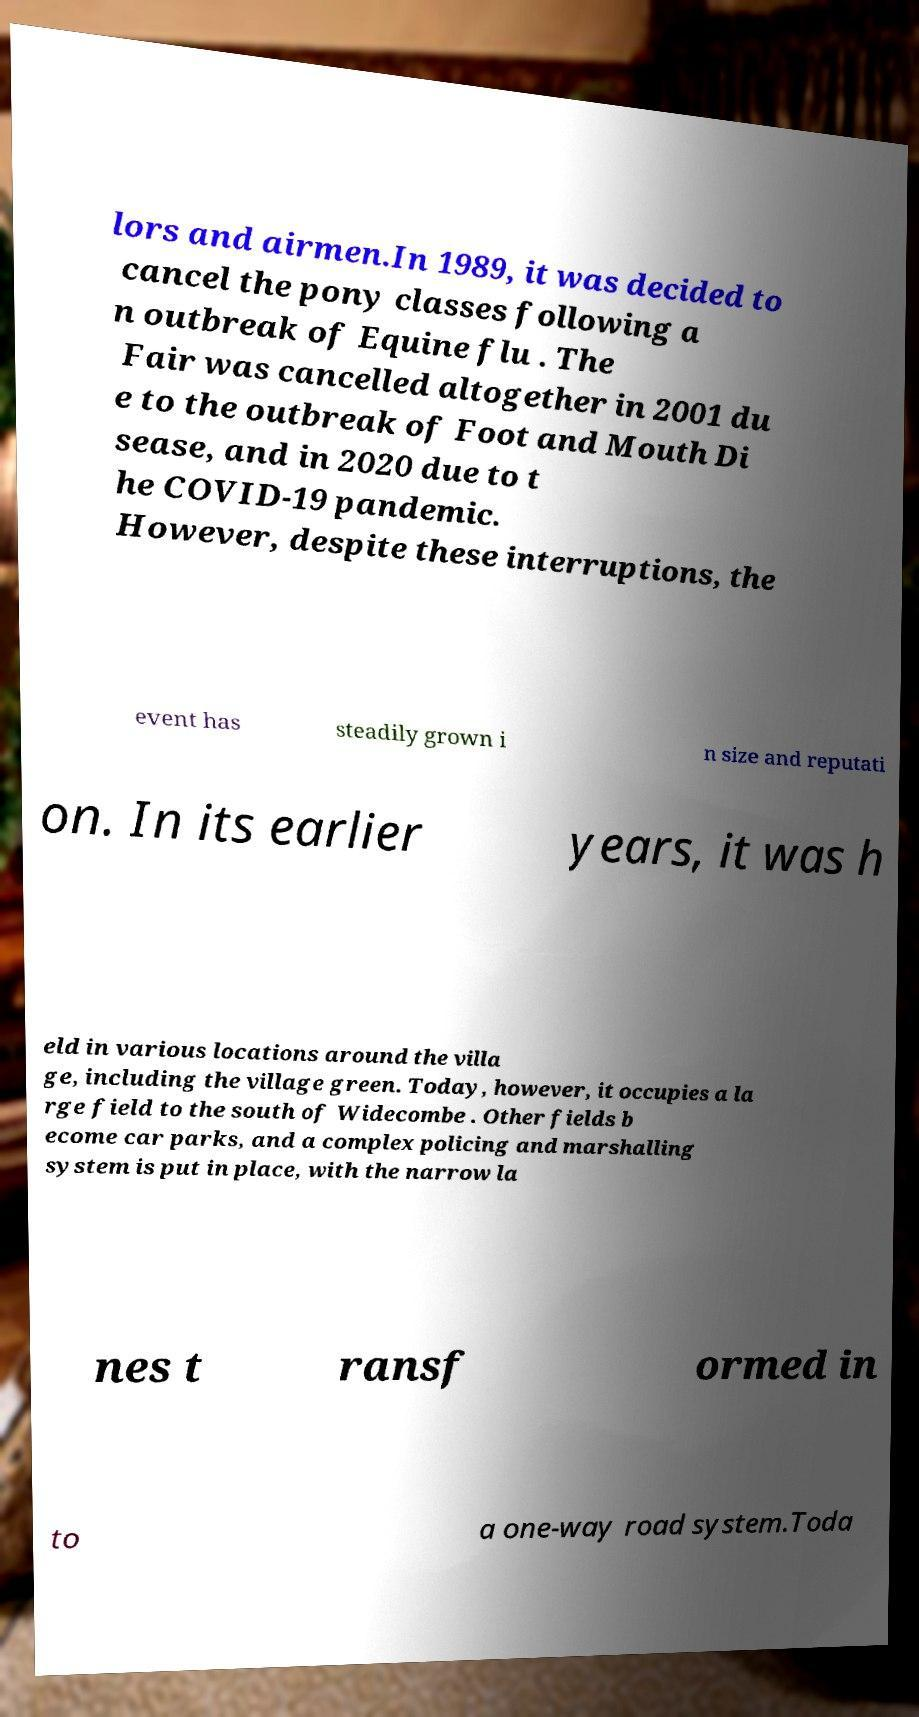Could you assist in decoding the text presented in this image and type it out clearly? lors and airmen.In 1989, it was decided to cancel the pony classes following a n outbreak of Equine flu . The Fair was cancelled altogether in 2001 du e to the outbreak of Foot and Mouth Di sease, and in 2020 due to t he COVID-19 pandemic. However, despite these interruptions, the event has steadily grown i n size and reputati on. In its earlier years, it was h eld in various locations around the villa ge, including the village green. Today, however, it occupies a la rge field to the south of Widecombe . Other fields b ecome car parks, and a complex policing and marshalling system is put in place, with the narrow la nes t ransf ormed in to a one-way road system.Toda 